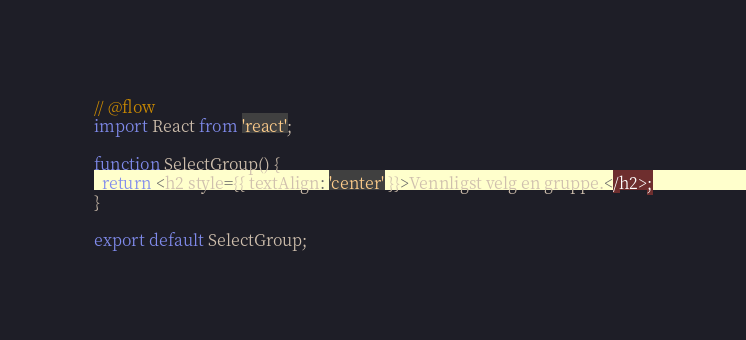<code> <loc_0><loc_0><loc_500><loc_500><_JavaScript_>// @flow
import React from 'react';

function SelectGroup() {
  return <h2 style={{ textAlign: 'center' }}>Vennligst velg en gruppe.</h2>;
}

export default SelectGroup;
</code> 